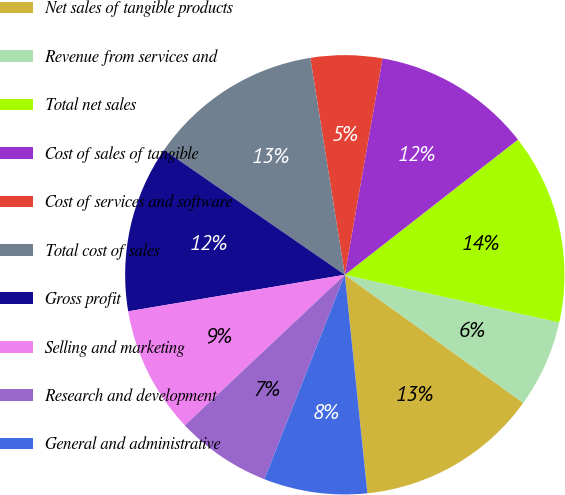Convert chart. <chart><loc_0><loc_0><loc_500><loc_500><pie_chart><fcel>Net sales of tangible products<fcel>Revenue from services and<fcel>Total net sales<fcel>Cost of sales of tangible<fcel>Cost of services and software<fcel>Total cost of sales<fcel>Gross profit<fcel>Selling and marketing<fcel>Research and development<fcel>General and administrative<nl><fcel>13.45%<fcel>6.43%<fcel>14.03%<fcel>11.7%<fcel>5.26%<fcel>12.87%<fcel>12.28%<fcel>9.36%<fcel>7.02%<fcel>7.6%<nl></chart> 